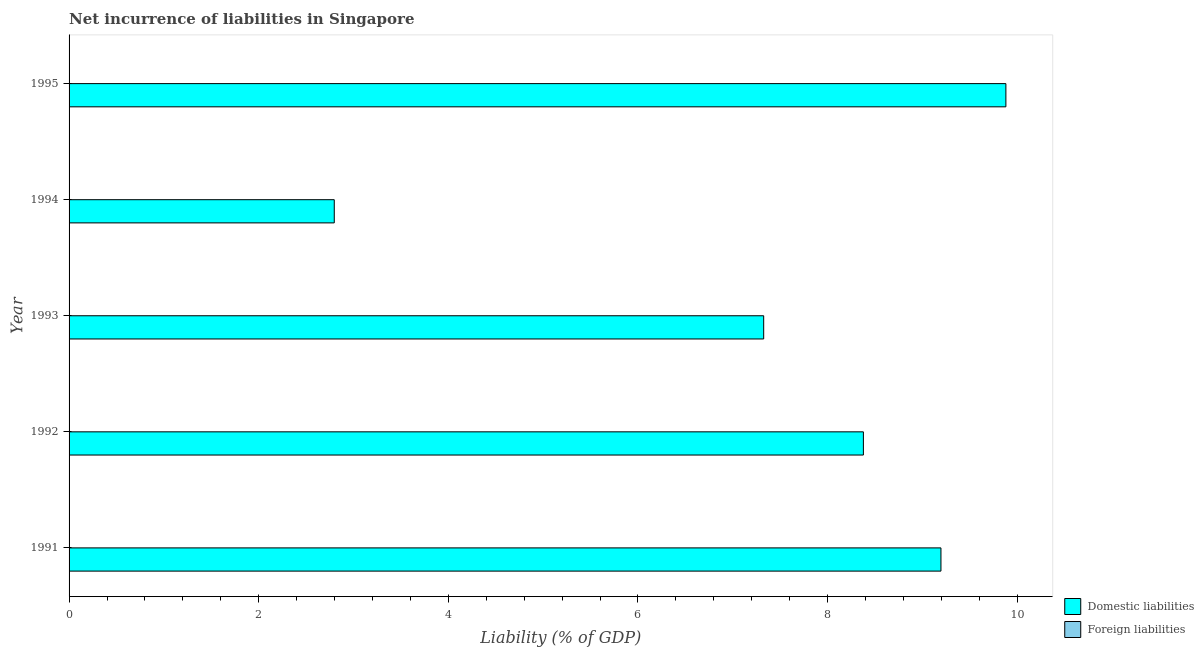How many different coloured bars are there?
Provide a succinct answer. 1. Are the number of bars on each tick of the Y-axis equal?
Offer a terse response. Yes. How many bars are there on the 2nd tick from the bottom?
Offer a very short reply. 1. What is the label of the 3rd group of bars from the top?
Provide a short and direct response. 1993. In how many cases, is the number of bars for a given year not equal to the number of legend labels?
Keep it short and to the point. 5. What is the incurrence of foreign liabilities in 1994?
Your answer should be compact. 0. Across all years, what is the maximum incurrence of domestic liabilities?
Your response must be concise. 9.88. Across all years, what is the minimum incurrence of domestic liabilities?
Your answer should be very brief. 2.8. What is the total incurrence of foreign liabilities in the graph?
Keep it short and to the point. 0. What is the difference between the incurrence of domestic liabilities in 1991 and that in 1994?
Ensure brevity in your answer.  6.4. What is the difference between the incurrence of domestic liabilities in 1992 and the incurrence of foreign liabilities in 1995?
Your answer should be very brief. 8.38. What is the average incurrence of domestic liabilities per year?
Ensure brevity in your answer.  7.52. In how many years, is the incurrence of domestic liabilities greater than 3.6 %?
Your answer should be very brief. 4. What is the ratio of the incurrence of domestic liabilities in 1992 to that in 1994?
Ensure brevity in your answer.  3. Is the incurrence of domestic liabilities in 1992 less than that in 1995?
Your answer should be compact. Yes. What is the difference between the highest and the second highest incurrence of domestic liabilities?
Provide a succinct answer. 0.69. What is the difference between the highest and the lowest incurrence of domestic liabilities?
Keep it short and to the point. 7.08. In how many years, is the incurrence of foreign liabilities greater than the average incurrence of foreign liabilities taken over all years?
Offer a very short reply. 0. How many bars are there?
Give a very brief answer. 5. How many years are there in the graph?
Offer a very short reply. 5. Does the graph contain grids?
Ensure brevity in your answer.  No. Where does the legend appear in the graph?
Your answer should be very brief. Bottom right. How are the legend labels stacked?
Make the answer very short. Vertical. What is the title of the graph?
Give a very brief answer. Net incurrence of liabilities in Singapore. Does "Fertility rate" appear as one of the legend labels in the graph?
Make the answer very short. No. What is the label or title of the X-axis?
Offer a very short reply. Liability (% of GDP). What is the Liability (% of GDP) in Domestic liabilities in 1991?
Offer a very short reply. 9.2. What is the Liability (% of GDP) in Domestic liabilities in 1992?
Give a very brief answer. 8.38. What is the Liability (% of GDP) in Domestic liabilities in 1993?
Make the answer very short. 7.33. What is the Liability (% of GDP) of Domestic liabilities in 1994?
Provide a short and direct response. 2.8. What is the Liability (% of GDP) in Domestic liabilities in 1995?
Provide a short and direct response. 9.88. What is the Liability (% of GDP) of Foreign liabilities in 1995?
Provide a succinct answer. 0. Across all years, what is the maximum Liability (% of GDP) in Domestic liabilities?
Your answer should be compact. 9.88. Across all years, what is the minimum Liability (% of GDP) in Domestic liabilities?
Give a very brief answer. 2.8. What is the total Liability (% of GDP) in Domestic liabilities in the graph?
Ensure brevity in your answer.  37.58. What is the difference between the Liability (% of GDP) of Domestic liabilities in 1991 and that in 1992?
Offer a very short reply. 0.82. What is the difference between the Liability (% of GDP) in Domestic liabilities in 1991 and that in 1993?
Give a very brief answer. 1.87. What is the difference between the Liability (% of GDP) in Domestic liabilities in 1991 and that in 1994?
Offer a terse response. 6.4. What is the difference between the Liability (% of GDP) in Domestic liabilities in 1991 and that in 1995?
Give a very brief answer. -0.68. What is the difference between the Liability (% of GDP) of Domestic liabilities in 1992 and that in 1993?
Your answer should be very brief. 1.05. What is the difference between the Liability (% of GDP) in Domestic liabilities in 1992 and that in 1994?
Provide a succinct answer. 5.58. What is the difference between the Liability (% of GDP) in Domestic liabilities in 1992 and that in 1995?
Keep it short and to the point. -1.5. What is the difference between the Liability (% of GDP) in Domestic liabilities in 1993 and that in 1994?
Make the answer very short. 4.53. What is the difference between the Liability (% of GDP) in Domestic liabilities in 1993 and that in 1995?
Give a very brief answer. -2.55. What is the difference between the Liability (% of GDP) in Domestic liabilities in 1994 and that in 1995?
Provide a short and direct response. -7.08. What is the average Liability (% of GDP) of Domestic liabilities per year?
Provide a short and direct response. 7.52. What is the average Liability (% of GDP) in Foreign liabilities per year?
Provide a short and direct response. 0. What is the ratio of the Liability (% of GDP) in Domestic liabilities in 1991 to that in 1992?
Make the answer very short. 1.1. What is the ratio of the Liability (% of GDP) of Domestic liabilities in 1991 to that in 1993?
Provide a succinct answer. 1.26. What is the ratio of the Liability (% of GDP) in Domestic liabilities in 1991 to that in 1994?
Give a very brief answer. 3.29. What is the ratio of the Liability (% of GDP) of Domestic liabilities in 1991 to that in 1995?
Offer a very short reply. 0.93. What is the ratio of the Liability (% of GDP) of Domestic liabilities in 1992 to that in 1993?
Provide a succinct answer. 1.14. What is the ratio of the Liability (% of GDP) of Domestic liabilities in 1992 to that in 1994?
Your answer should be compact. 3. What is the ratio of the Liability (% of GDP) in Domestic liabilities in 1992 to that in 1995?
Keep it short and to the point. 0.85. What is the ratio of the Liability (% of GDP) of Domestic liabilities in 1993 to that in 1994?
Your answer should be compact. 2.62. What is the ratio of the Liability (% of GDP) of Domestic liabilities in 1993 to that in 1995?
Provide a succinct answer. 0.74. What is the ratio of the Liability (% of GDP) of Domestic liabilities in 1994 to that in 1995?
Your response must be concise. 0.28. What is the difference between the highest and the second highest Liability (% of GDP) in Domestic liabilities?
Your answer should be compact. 0.68. What is the difference between the highest and the lowest Liability (% of GDP) in Domestic liabilities?
Provide a short and direct response. 7.08. 